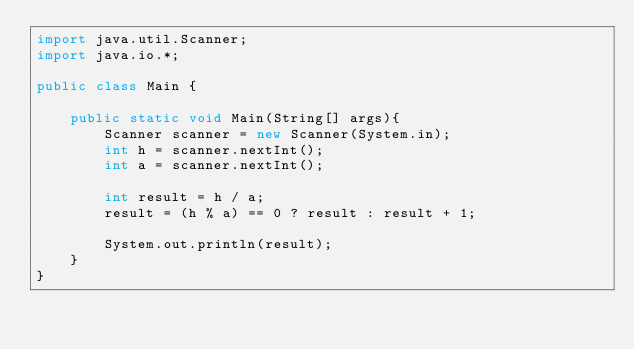Convert code to text. <code><loc_0><loc_0><loc_500><loc_500><_Java_>import java.util.Scanner;
import java.io.*;

public class Main {

    public static void Main(String[] args){
        Scanner scanner = new Scanner(System.in);
        int h = scanner.nextInt();
        int a = scanner.nextInt();

        int result = h / a;
        result = (h % a) == 0 ? result : result + 1;

        System.out.println(result);
    }
}</code> 